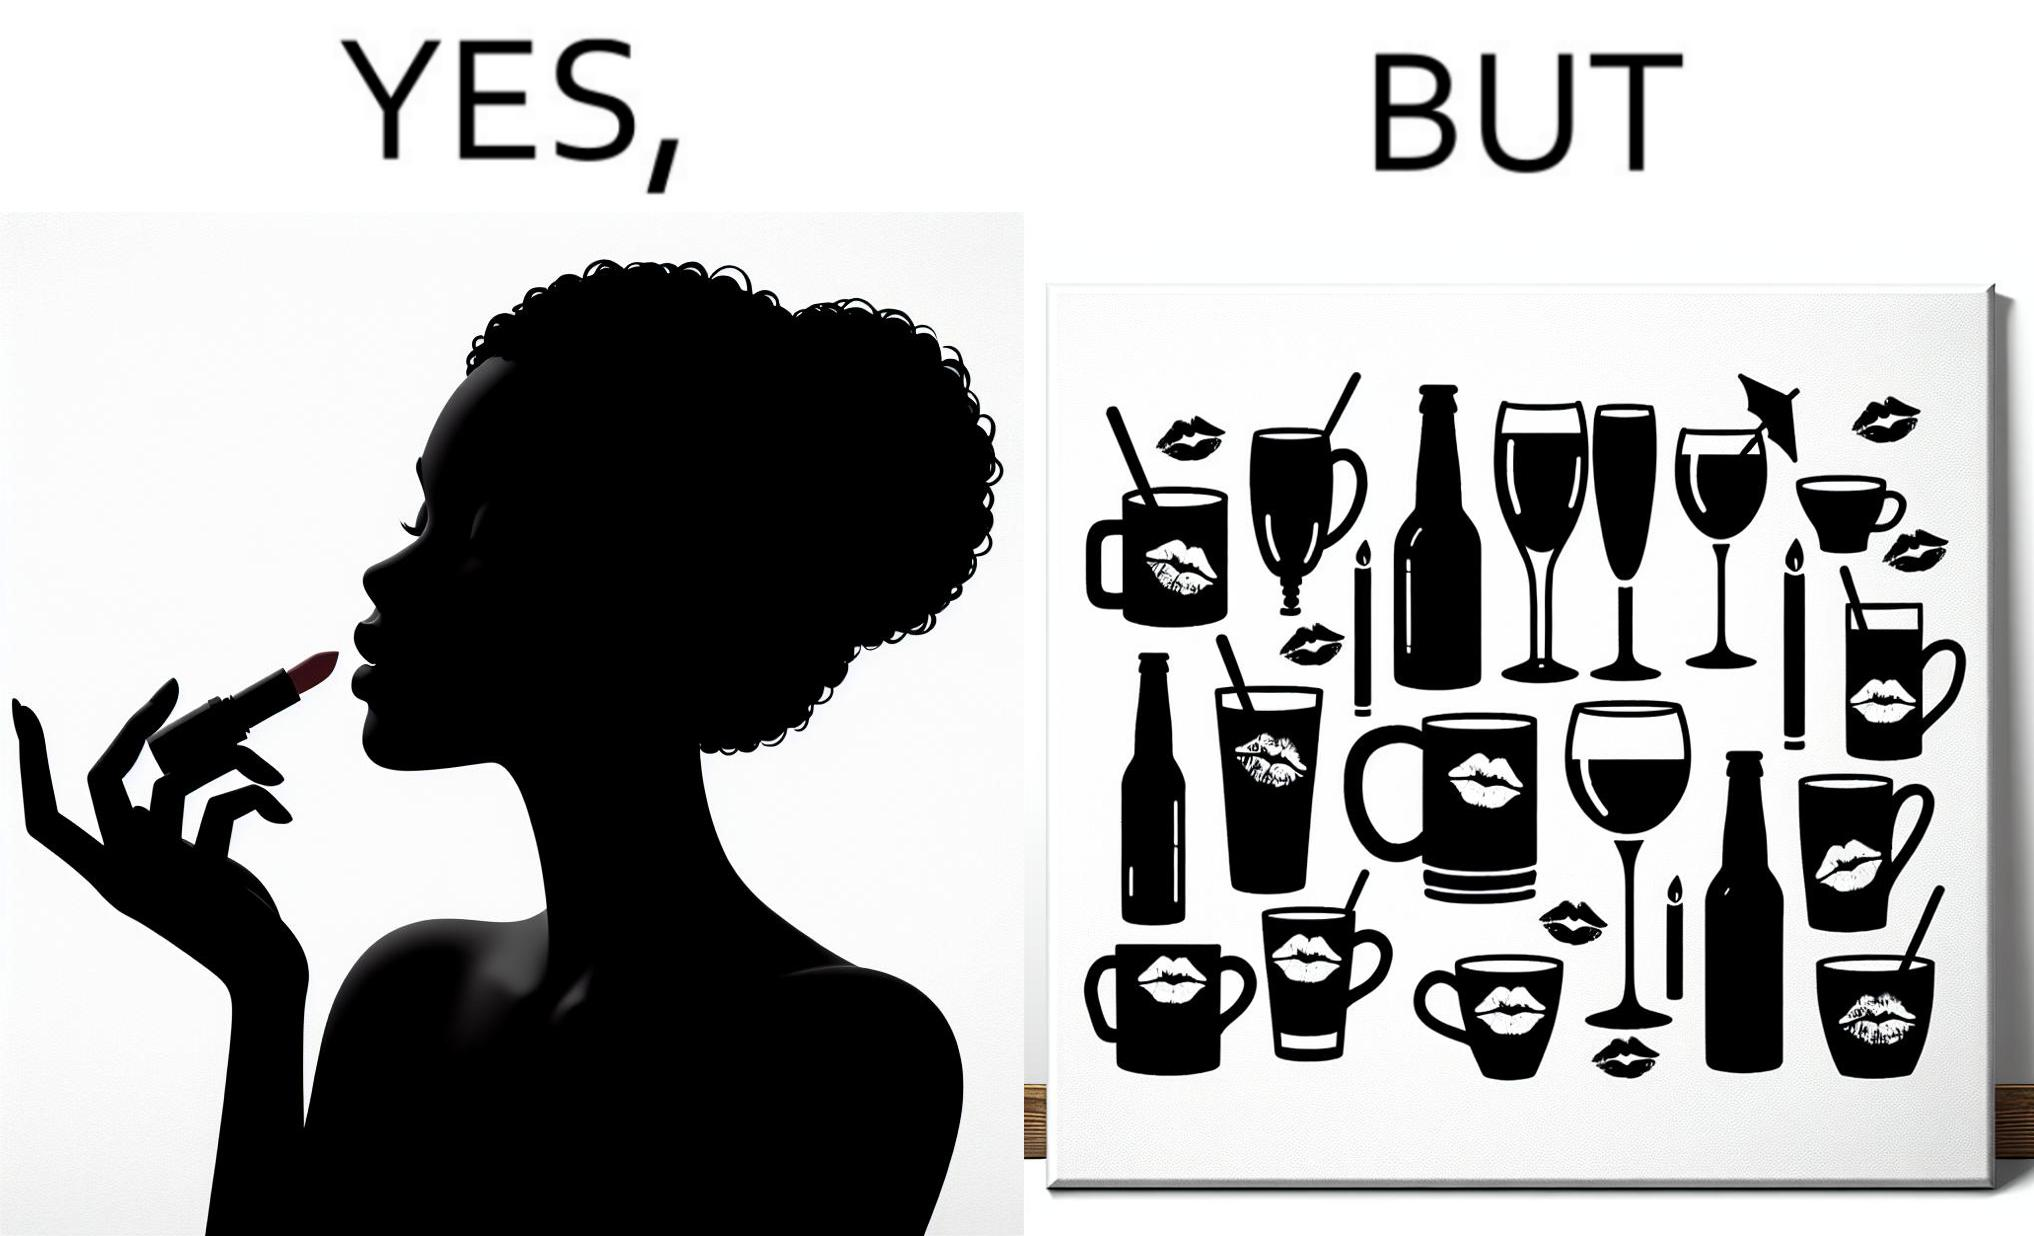Is there satirical content in this image? Yes, this image is satirical. 